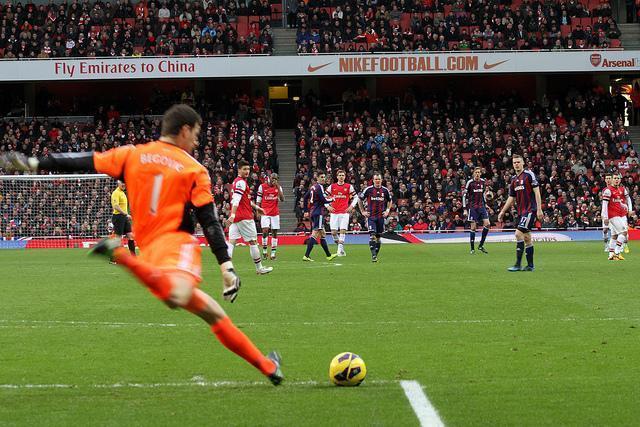How many people can you see?
Give a very brief answer. 4. 